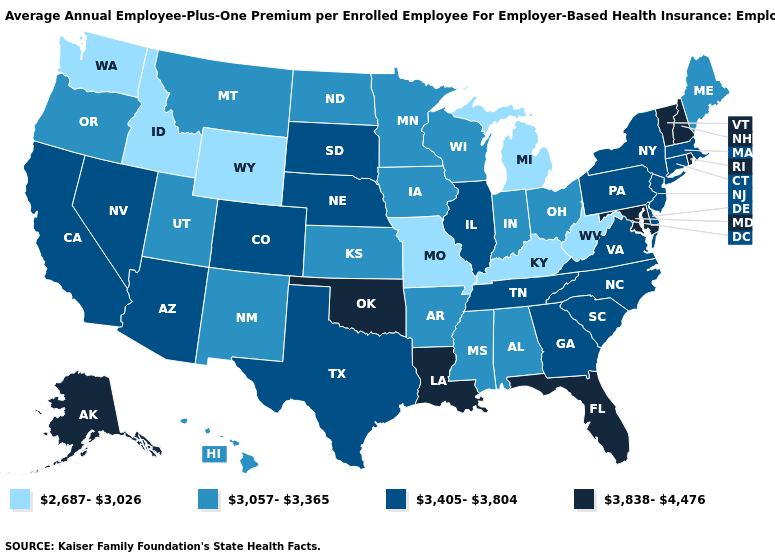Does Idaho have the same value as Wyoming?
Quick response, please. Yes. What is the value of Washington?
Keep it brief. 2,687-3,026. What is the value of Mississippi?
Short answer required. 3,057-3,365. Which states hav the highest value in the MidWest?
Short answer required. Illinois, Nebraska, South Dakota. What is the value of North Carolina?
Quick response, please. 3,405-3,804. What is the value of Oklahoma?
Short answer required. 3,838-4,476. Is the legend a continuous bar?
Quick response, please. No. What is the lowest value in the USA?
Keep it brief. 2,687-3,026. How many symbols are there in the legend?
Short answer required. 4. How many symbols are there in the legend?
Concise answer only. 4. What is the value of West Virginia?
Answer briefly. 2,687-3,026. Does West Virginia have the lowest value in the South?
Keep it brief. Yes. Name the states that have a value in the range 3,057-3,365?
Be succinct. Alabama, Arkansas, Hawaii, Indiana, Iowa, Kansas, Maine, Minnesota, Mississippi, Montana, New Mexico, North Dakota, Ohio, Oregon, Utah, Wisconsin. Name the states that have a value in the range 3,838-4,476?
Be succinct. Alaska, Florida, Louisiana, Maryland, New Hampshire, Oklahoma, Rhode Island, Vermont. What is the highest value in the USA?
Write a very short answer. 3,838-4,476. 